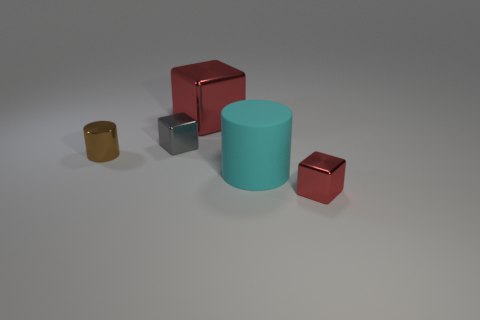Add 2 big red things. How many objects exist? 7 Subtract 1 cubes. How many cubes are left? 2 Subtract all cyan cylinders. How many cylinders are left? 1 Subtract 1 gray cubes. How many objects are left? 4 Subtract all cubes. How many objects are left? 2 Subtract all blue cylinders. Subtract all purple cubes. How many cylinders are left? 2 Subtract all cyan balls. How many blue cylinders are left? 0 Subtract all blue rubber cylinders. Subtract all big red objects. How many objects are left? 4 Add 5 tiny brown metallic cylinders. How many tiny brown metallic cylinders are left? 6 Add 5 small red metal cubes. How many small red metal cubes exist? 6 